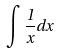<formula> <loc_0><loc_0><loc_500><loc_500>\int \frac { 1 } { x } d x</formula> 